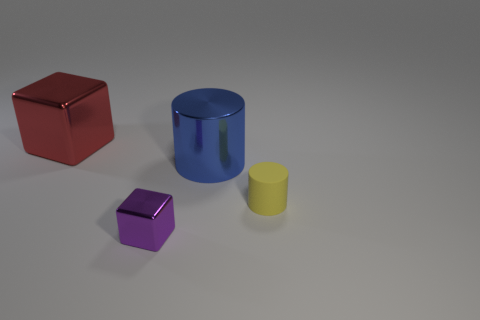There is a rubber object in front of the red shiny object; does it have the same shape as the blue thing?
Ensure brevity in your answer.  Yes. Is there a purple metal cylinder that has the same size as the blue metal thing?
Give a very brief answer. No. Is there a purple metallic thing right of the big thing left of the block that is in front of the blue thing?
Your response must be concise. Yes. There is a tiny rubber object; is it the same color as the metal block that is in front of the large metallic block?
Make the answer very short. No. What is the tiny object that is right of the tiny object left of the cylinder that is right of the large blue cylinder made of?
Make the answer very short. Rubber. There is a big shiny thing that is to the left of the big blue metal cylinder; what is its shape?
Offer a very short reply. Cube. What size is the purple thing that is the same material as the blue cylinder?
Provide a succinct answer. Small. How many purple shiny things are the same shape as the blue metal object?
Your answer should be very brief. 0. There is a block behind the metal object that is in front of the rubber thing; what number of blue metal cylinders are behind it?
Give a very brief answer. 0. What number of things are right of the tiny shiny block and behind the yellow cylinder?
Provide a short and direct response. 1. 